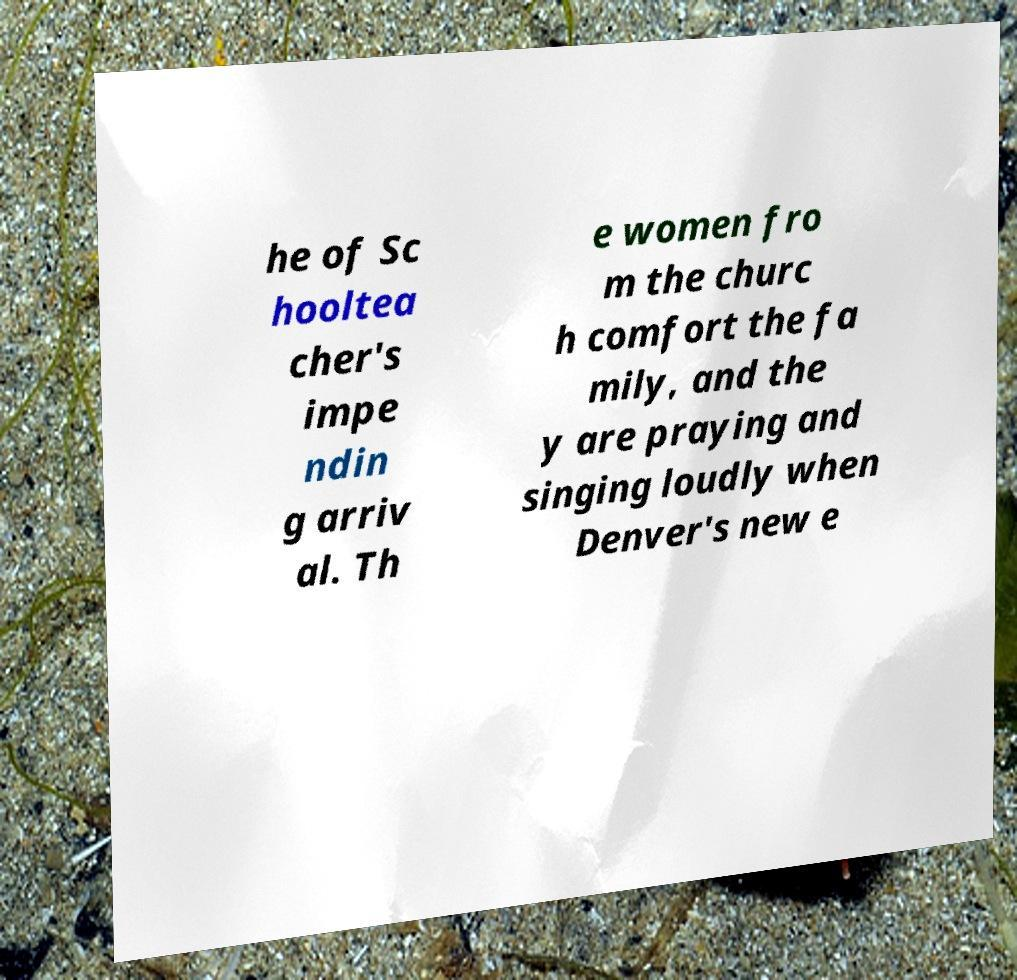Could you assist in decoding the text presented in this image and type it out clearly? he of Sc hooltea cher's impe ndin g arriv al. Th e women fro m the churc h comfort the fa mily, and the y are praying and singing loudly when Denver's new e 